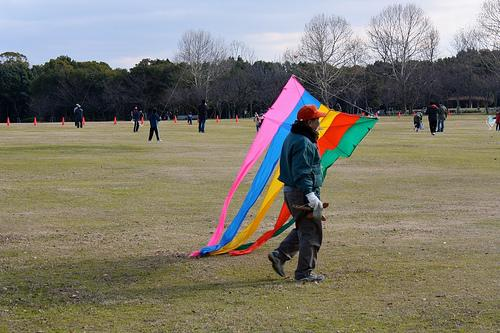Which color of the rainbow is missing from this kite? Please explain your reasoning. yellow. Unless you are colorblind you can easily tell what color is missing. 